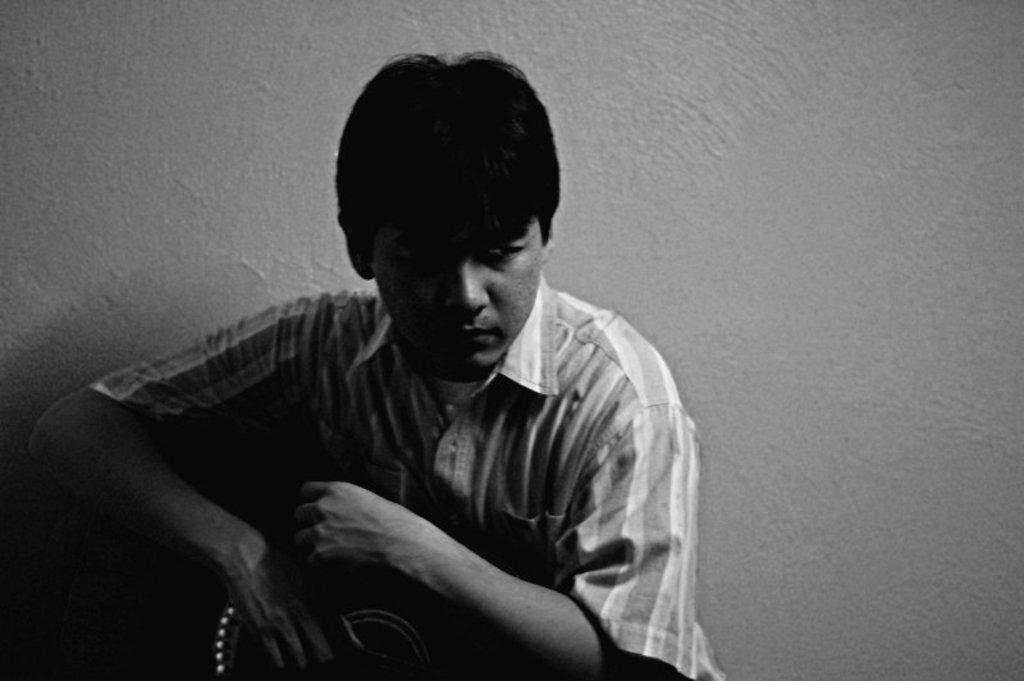What is present in the image? There is a man in the image. What is the man doing in the image? The man is holding an object in his hand. What can be seen in the background of the image? There is a wall in the background of the image. What type of digestion can be observed in the image? There is no digestion present in the image; it features a man holding an object in his hand with a wall in the background. Can you tell me what type of wrench the man is holding in the image? The object the man is holding in his hand is not specified as a wrench in the provided facts, so it cannot be determined from the image. 